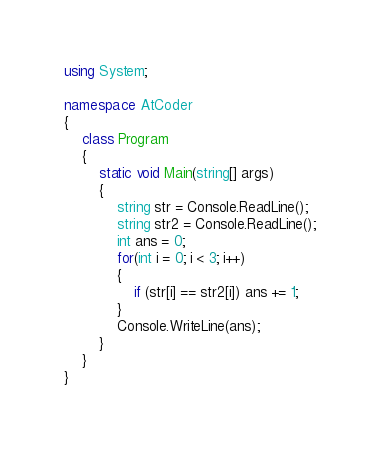Convert code to text. <code><loc_0><loc_0><loc_500><loc_500><_C#_>using System;

namespace AtCoder
{
    class Program
    {
        static void Main(string[] args)
        {
            string str = Console.ReadLine();
            string str2 = Console.ReadLine();
            int ans = 0;
            for(int i = 0; i < 3; i++)
            {
                if (str[i] == str2[i]) ans += 1;
            }
            Console.WriteLine(ans);
        }
    }
}
</code> 